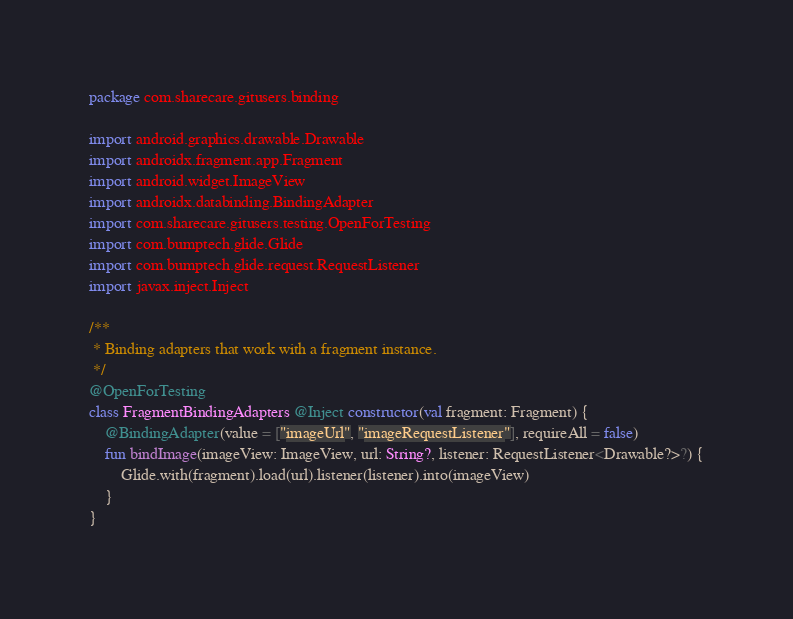<code> <loc_0><loc_0><loc_500><loc_500><_Kotlin_>package com.sharecare.gitusers.binding

import android.graphics.drawable.Drawable
import androidx.fragment.app.Fragment
import android.widget.ImageView
import androidx.databinding.BindingAdapter
import com.sharecare.gitusers.testing.OpenForTesting
import com.bumptech.glide.Glide
import com.bumptech.glide.request.RequestListener
import javax.inject.Inject

/**
 * Binding adapters that work with a fragment instance.
 */
@OpenForTesting
class FragmentBindingAdapters @Inject constructor(val fragment: Fragment) {
    @BindingAdapter(value = ["imageUrl", "imageRequestListener"], requireAll = false)
    fun bindImage(imageView: ImageView, url: String?, listener: RequestListener<Drawable?>?) {
        Glide.with(fragment).load(url).listener(listener).into(imageView)
    }
}

</code> 